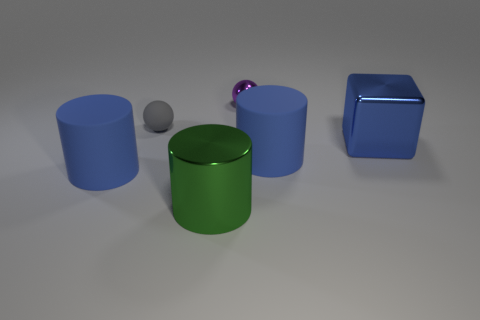Subtract all green cylinders. How many cylinders are left? 2 Add 1 tiny balls. How many tiny balls are left? 3 Add 1 tiny yellow matte cubes. How many tiny yellow matte cubes exist? 1 Add 3 purple balls. How many objects exist? 9 Subtract all green cylinders. How many cylinders are left? 2 Subtract 0 brown blocks. How many objects are left? 6 Subtract all cubes. How many objects are left? 5 Subtract 2 cylinders. How many cylinders are left? 1 Subtract all red cubes. Subtract all yellow cylinders. How many cubes are left? 1 Subtract all yellow spheres. How many green cylinders are left? 1 